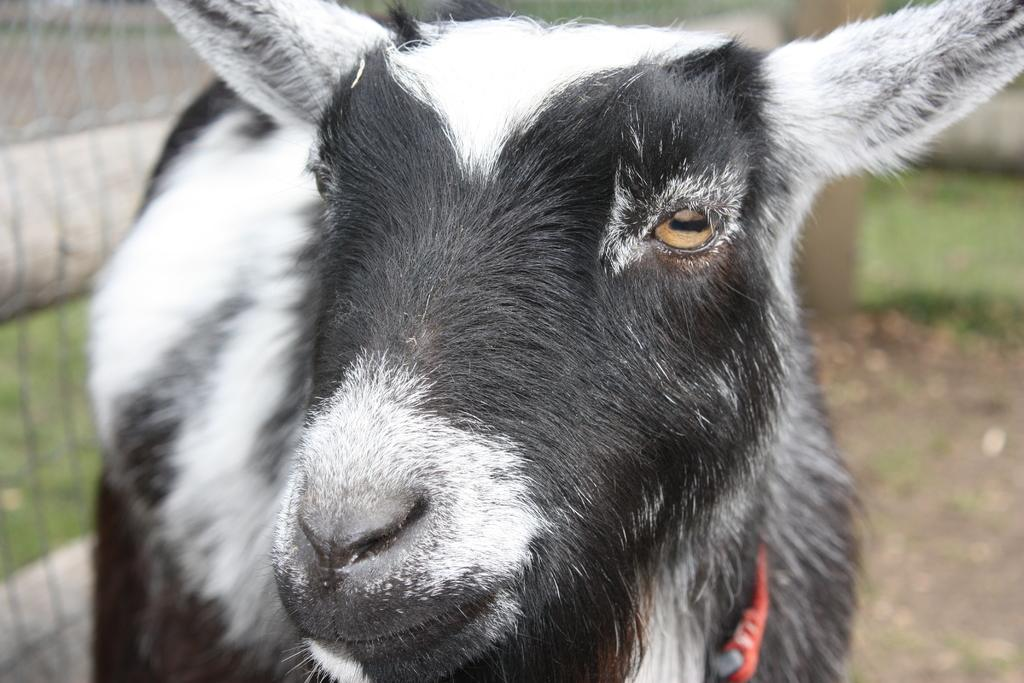What animal is in the middle of the image? There is a goat in the middle of the image. What can be seen on the left side of the image? There is a mesh on the left side of the image. What type of fiction is the goat reading in the image? There is no indication in the image that the goat is reading any fiction, as goats do not read. 